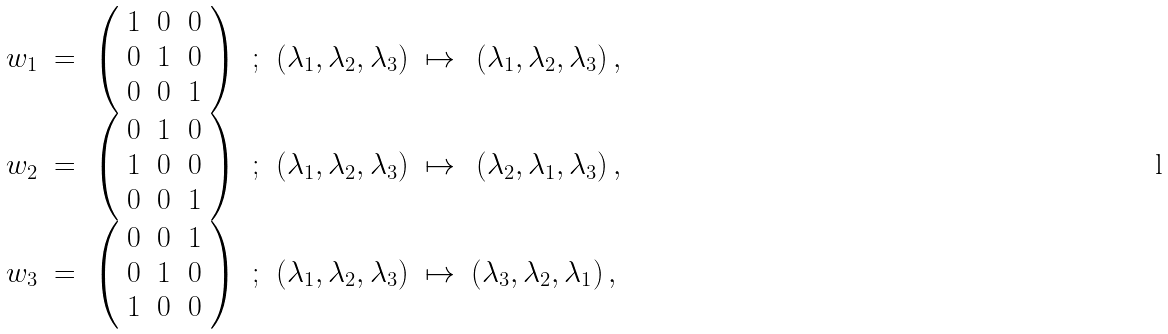<formula> <loc_0><loc_0><loc_500><loc_500>\begin{array} { c c c c c c c } w _ { 1 } & = & \left ( \begin{array} { l l l } 1 & 0 & 0 \\ 0 & 1 & 0 \\ 0 & 0 & 1 \end{array} \right ) & ; & \left ( \lambda _ { 1 } , \lambda _ { 2 } , \lambda _ { 3 } \right ) & \mapsto & \left ( \lambda _ { 1 } , \lambda _ { 2 } , \lambda _ { 3 } \right ) , \\ w _ { 2 } & = & \left ( \begin{array} { l l l } 0 & 1 & 0 \\ 1 & 0 & 0 \\ 0 & 0 & 1 \end{array} \right ) & ; & \left ( \lambda _ { 1 } , \lambda _ { 2 } , \lambda _ { 3 } \right ) & \mapsto & \left ( \lambda _ { 2 } , \lambda _ { 1 } , \lambda _ { 3 } \right ) , \\ w _ { 3 } & = & \left ( \begin{array} { l l l } 0 & 0 & 1 \\ 0 & 1 & 0 \\ 1 & 0 & 0 \end{array} \right ) & ; & \left ( \lambda _ { 1 } , \lambda _ { 2 } , \lambda _ { 3 } \right ) & \mapsto & \left ( \lambda _ { 3 } , \lambda _ { 2 } , \lambda _ { 1 } \right ) , \ \end{array}</formula> 